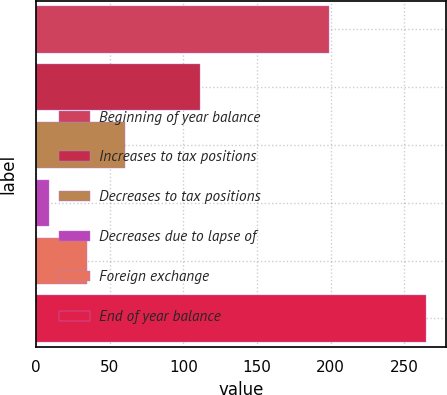Convert chart. <chart><loc_0><loc_0><loc_500><loc_500><bar_chart><fcel>Beginning of year balance<fcel>Increases to tax positions<fcel>Decreases to tax positions<fcel>Decreases due to lapse of<fcel>Foreign exchange<fcel>End of year balance<nl><fcel>199<fcel>111.4<fcel>60.2<fcel>9<fcel>34.6<fcel>265<nl></chart> 